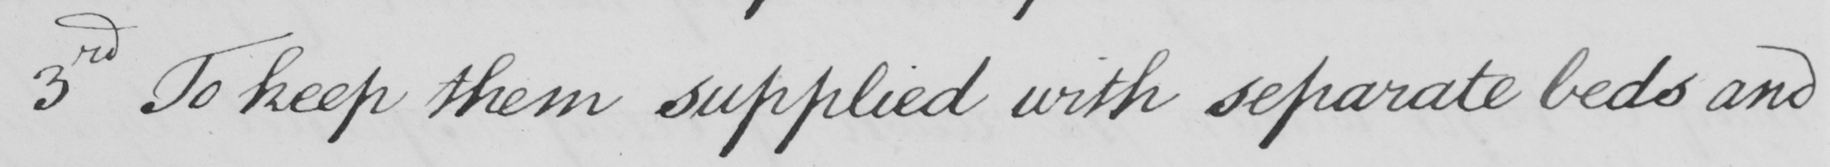Please provide the text content of this handwritten line. 3rd To keep them supplied with separate beds and 